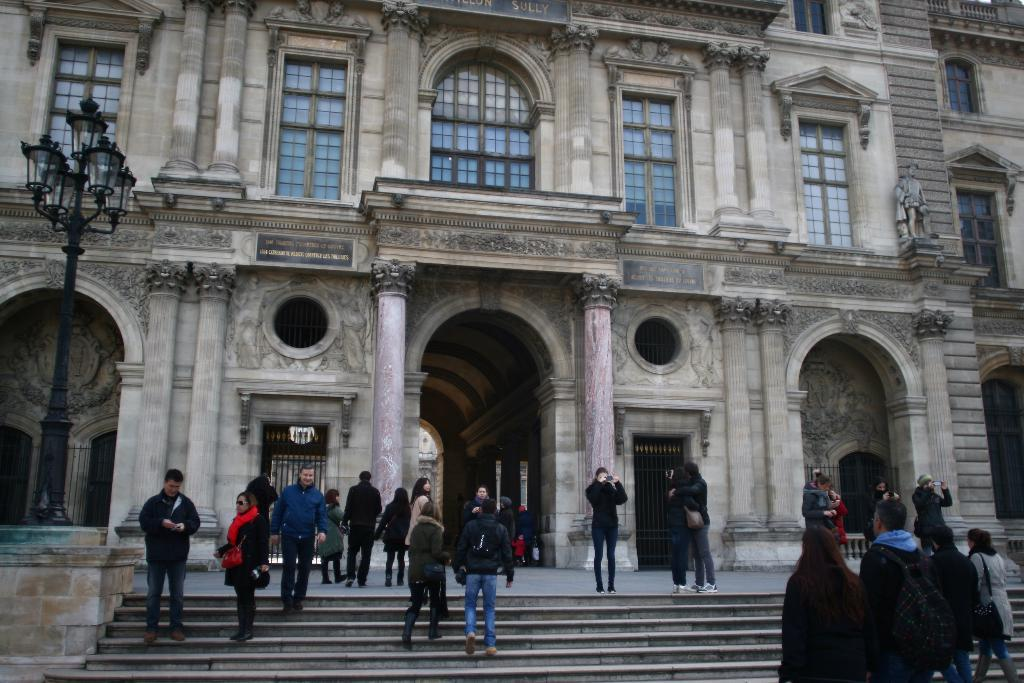What type of structure is visible in the image? There is a building in the image. What are the people in the image wearing? There are persons wearing clothes in the image. What can be seen on the left side of the image? There is a street lamp on the left side of the image. What architectural feature is present at the bottom of the image? There are stairs at the bottom of the image. What type of seed can be seen growing on the building in the image? There is no seed visible on the building in the image. Can you describe the coat that the person on the right is wearing? There is no person on the right in the image, and no coat is mentioned in the provided facts. 